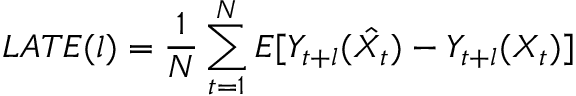<formula> <loc_0><loc_0><loc_500><loc_500>L A T E ( l ) = \frac { 1 } { N } \sum _ { t = 1 } ^ { N } E [ Y _ { t + l } ( \hat { X _ { t } } ) - Y _ { t + l } ( X _ { t } ) ]</formula> 